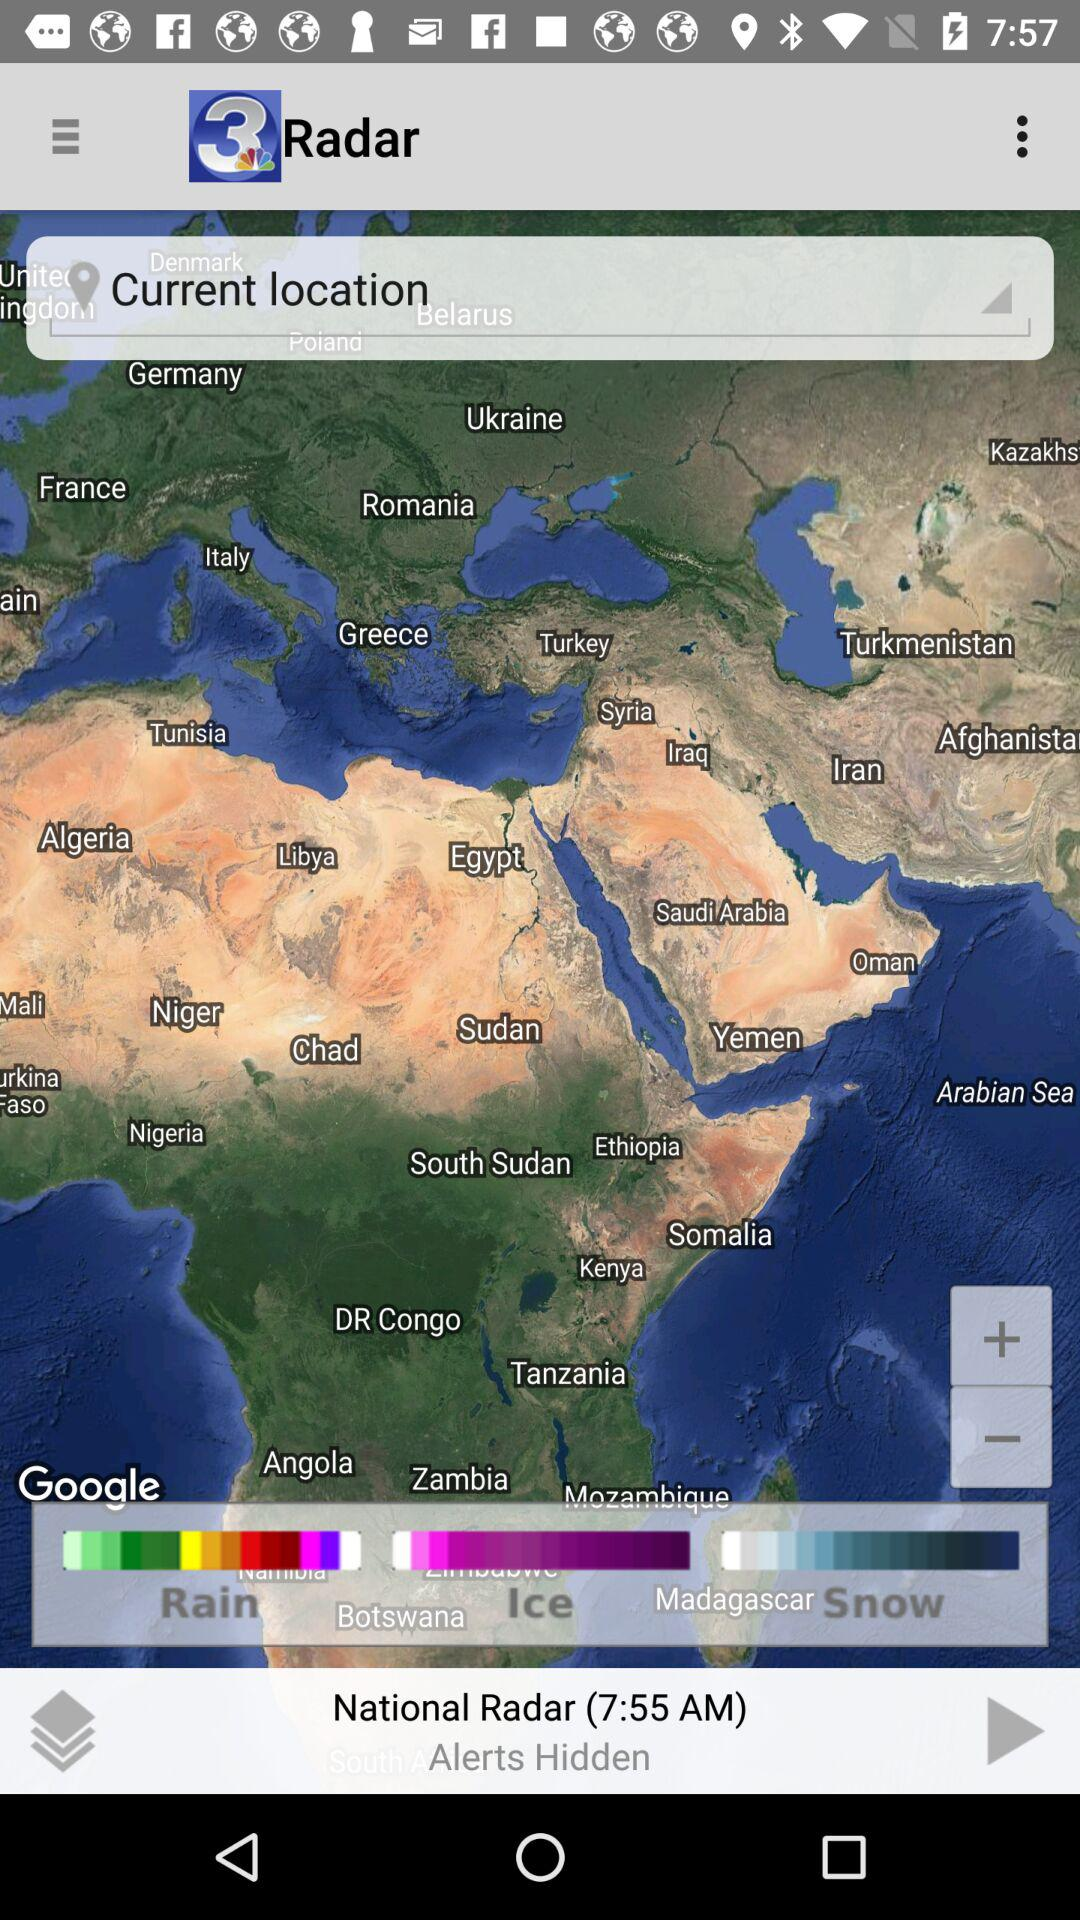What is the application name? The application name is "News3LV KSNV Las Vegas News". 